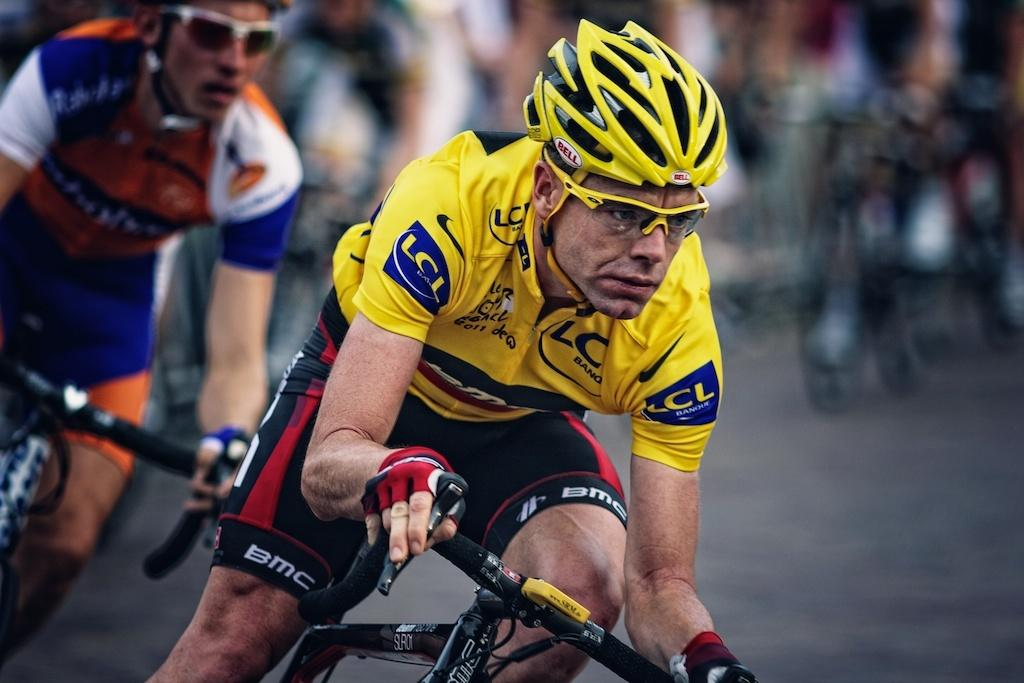What are the people in the image doing? The people in the image are riding bicycles. What activity are the people participating in? The people are participating in a race. What type of surface can be seen in the image? There is a road in the image. How is the background of the image depicted? The background of the image is blurred. What type of breakfast is being served in the image? There is no breakfast present in the image; it features people riding bicycles in a race. Can you describe the picture hanging on the wall in the image? There is no picture hanging on the wall in the image; the background is blurred. 